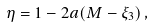<formula> <loc_0><loc_0><loc_500><loc_500>\eta = 1 - 2 a ( M - \xi _ { 3 } ) \, ,</formula> 